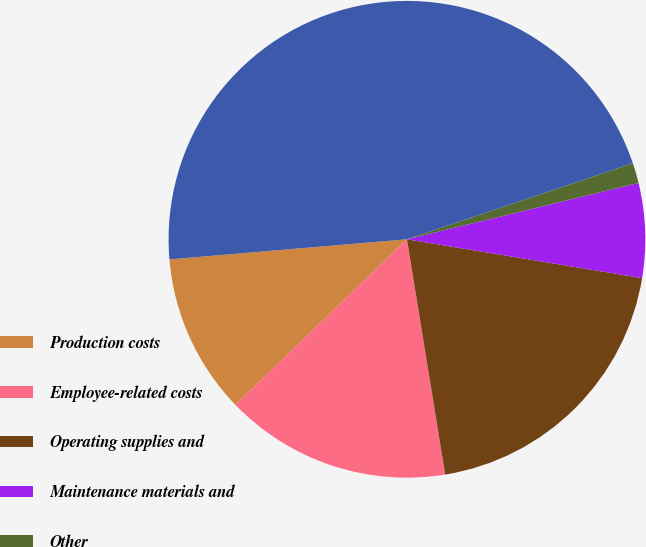Convert chart. <chart><loc_0><loc_0><loc_500><loc_500><pie_chart><fcel>Production costs<fcel>Employee-related costs<fcel>Operating supplies and<fcel>Maintenance materials and<fcel>Other<fcel>Total<nl><fcel>10.87%<fcel>15.35%<fcel>19.83%<fcel>6.4%<fcel>1.38%<fcel>46.16%<nl></chart> 